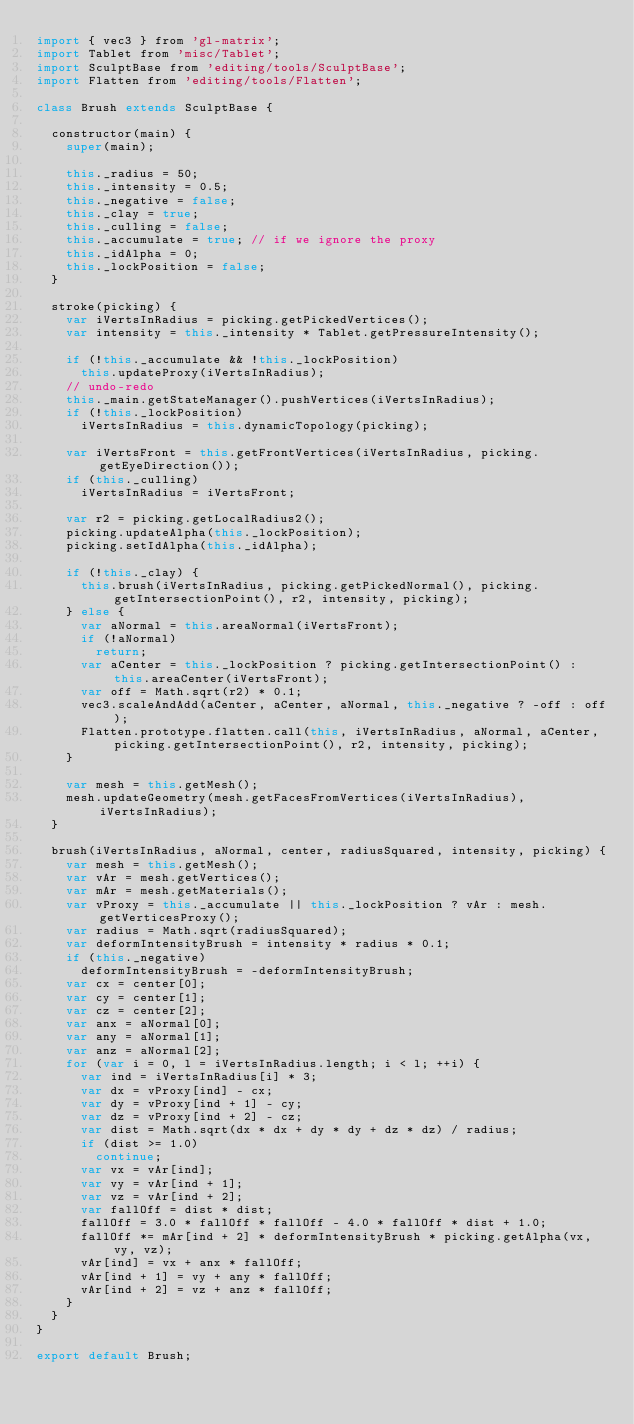<code> <loc_0><loc_0><loc_500><loc_500><_JavaScript_>import { vec3 } from 'gl-matrix';
import Tablet from 'misc/Tablet';
import SculptBase from 'editing/tools/SculptBase';
import Flatten from 'editing/tools/Flatten';

class Brush extends SculptBase {

  constructor(main) {
    super(main);

    this._radius = 50;
    this._intensity = 0.5;
    this._negative = false;
    this._clay = true;
    this._culling = false;
    this._accumulate = true; // if we ignore the proxy
    this._idAlpha = 0;
    this._lockPosition = false;
  }

  stroke(picking) {
    var iVertsInRadius = picking.getPickedVertices();
    var intensity = this._intensity * Tablet.getPressureIntensity();

    if (!this._accumulate && !this._lockPosition)
      this.updateProxy(iVertsInRadius);
    // undo-redo
    this._main.getStateManager().pushVertices(iVertsInRadius);
    if (!this._lockPosition)
      iVertsInRadius = this.dynamicTopology(picking);

    var iVertsFront = this.getFrontVertices(iVertsInRadius, picking.getEyeDirection());
    if (this._culling)
      iVertsInRadius = iVertsFront;

    var r2 = picking.getLocalRadius2();
    picking.updateAlpha(this._lockPosition);
    picking.setIdAlpha(this._idAlpha);

    if (!this._clay) {
      this.brush(iVertsInRadius, picking.getPickedNormal(), picking.getIntersectionPoint(), r2, intensity, picking);
    } else {
      var aNormal = this.areaNormal(iVertsFront);
      if (!aNormal)
        return;
      var aCenter = this._lockPosition ? picking.getIntersectionPoint() : this.areaCenter(iVertsFront);
      var off = Math.sqrt(r2) * 0.1;
      vec3.scaleAndAdd(aCenter, aCenter, aNormal, this._negative ? -off : off);
      Flatten.prototype.flatten.call(this, iVertsInRadius, aNormal, aCenter, picking.getIntersectionPoint(), r2, intensity, picking);
    }

    var mesh = this.getMesh();
    mesh.updateGeometry(mesh.getFacesFromVertices(iVertsInRadius), iVertsInRadius);
  }

  brush(iVertsInRadius, aNormal, center, radiusSquared, intensity, picking) {
    var mesh = this.getMesh();
    var vAr = mesh.getVertices();
    var mAr = mesh.getMaterials();
    var vProxy = this._accumulate || this._lockPosition ? vAr : mesh.getVerticesProxy();
    var radius = Math.sqrt(radiusSquared);
    var deformIntensityBrush = intensity * radius * 0.1;
    if (this._negative)
      deformIntensityBrush = -deformIntensityBrush;
    var cx = center[0];
    var cy = center[1];
    var cz = center[2];
    var anx = aNormal[0];
    var any = aNormal[1];
    var anz = aNormal[2];
    for (var i = 0, l = iVertsInRadius.length; i < l; ++i) {
      var ind = iVertsInRadius[i] * 3;
      var dx = vProxy[ind] - cx;
      var dy = vProxy[ind + 1] - cy;
      var dz = vProxy[ind + 2] - cz;
      var dist = Math.sqrt(dx * dx + dy * dy + dz * dz) / radius;
      if (dist >= 1.0)
        continue;
      var vx = vAr[ind];
      var vy = vAr[ind + 1];
      var vz = vAr[ind + 2];
      var fallOff = dist * dist;
      fallOff = 3.0 * fallOff * fallOff - 4.0 * fallOff * dist + 1.0;
      fallOff *= mAr[ind + 2] * deformIntensityBrush * picking.getAlpha(vx, vy, vz);
      vAr[ind] = vx + anx * fallOff;
      vAr[ind + 1] = vy + any * fallOff;
      vAr[ind + 2] = vz + anz * fallOff;
    }
  }
}

export default Brush;
</code> 